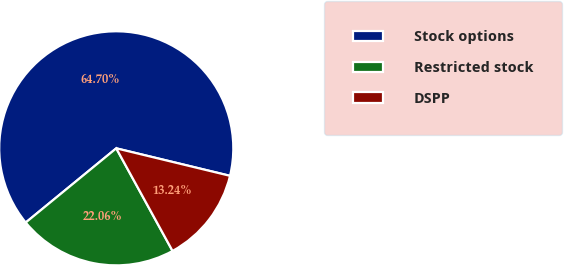Convert chart to OTSL. <chart><loc_0><loc_0><loc_500><loc_500><pie_chart><fcel>Stock options<fcel>Restricted stock<fcel>DSPP<nl><fcel>64.71%<fcel>22.06%<fcel>13.24%<nl></chart> 